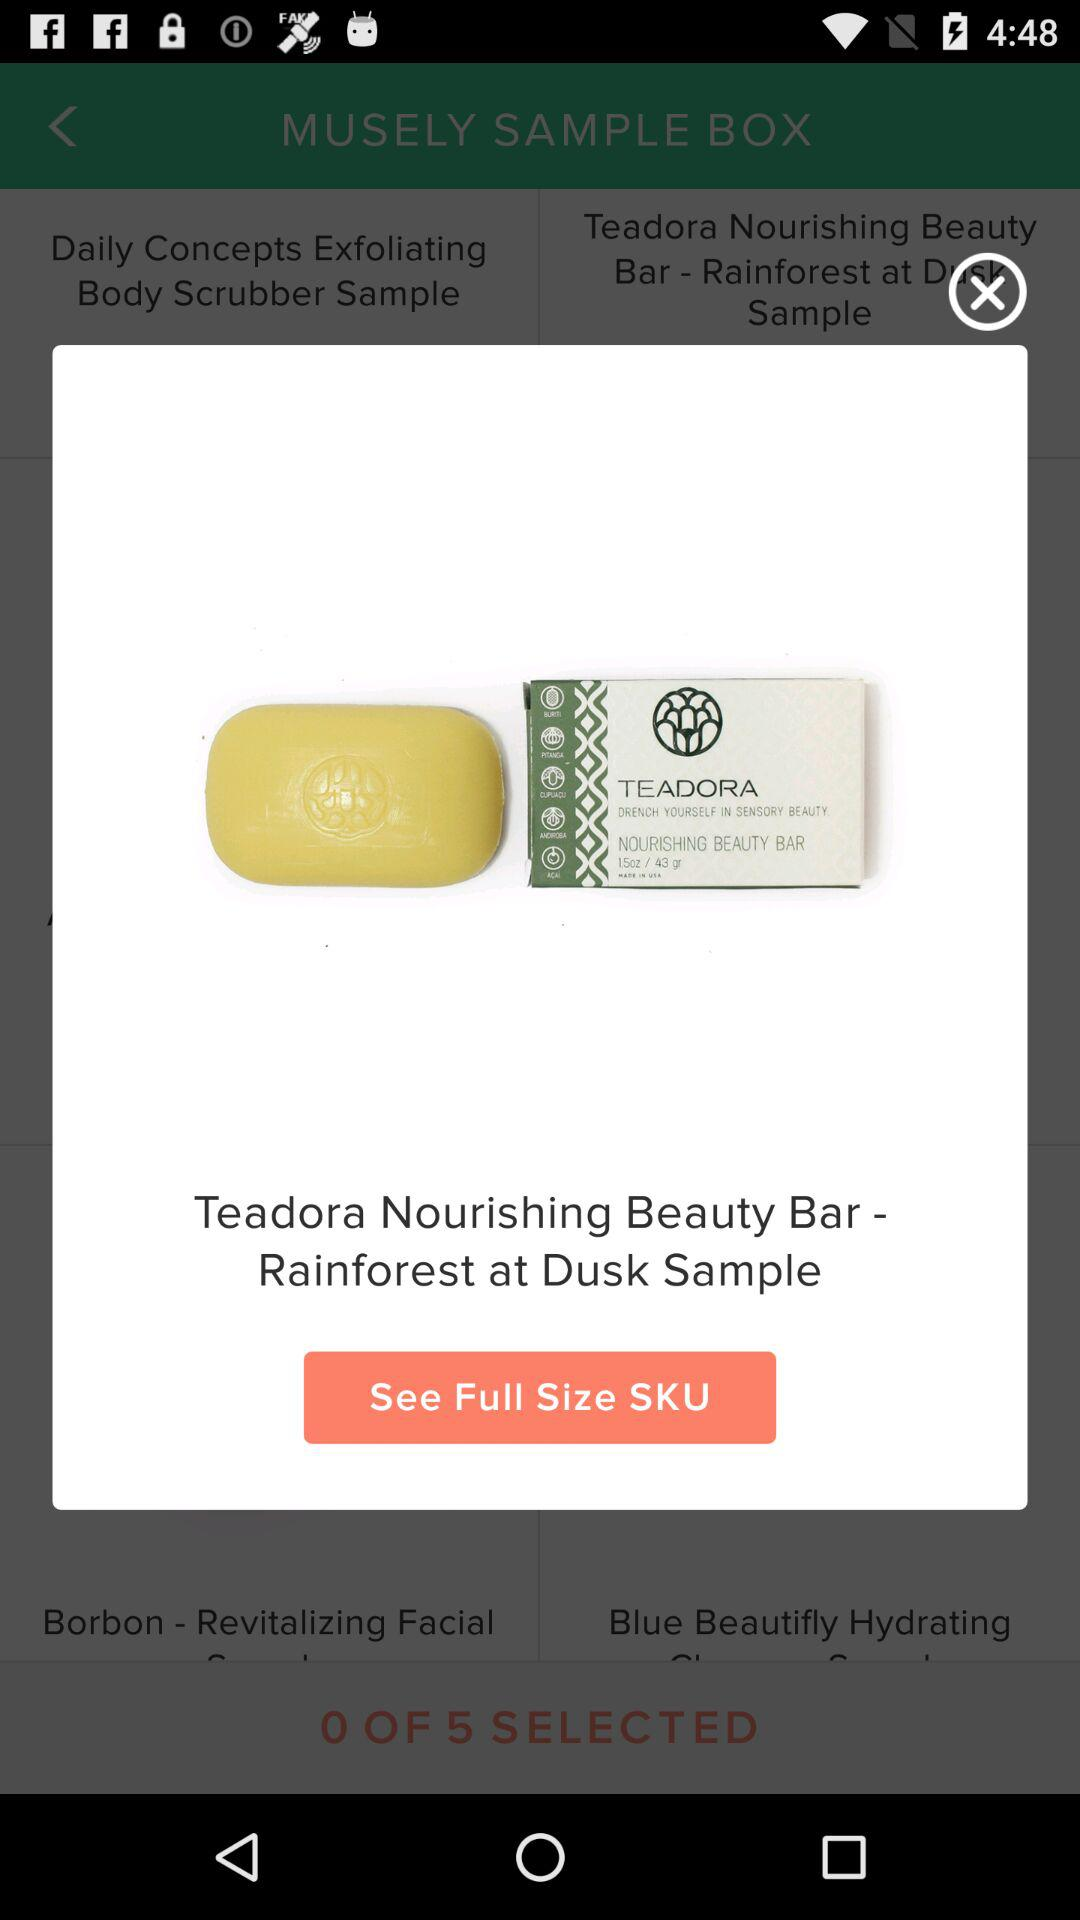How much does the "Teadora Nourishing Beauty Bar - Rainforest at Dusk Sample" cost?
When the provided information is insufficient, respond with <no answer>. <no answer> 